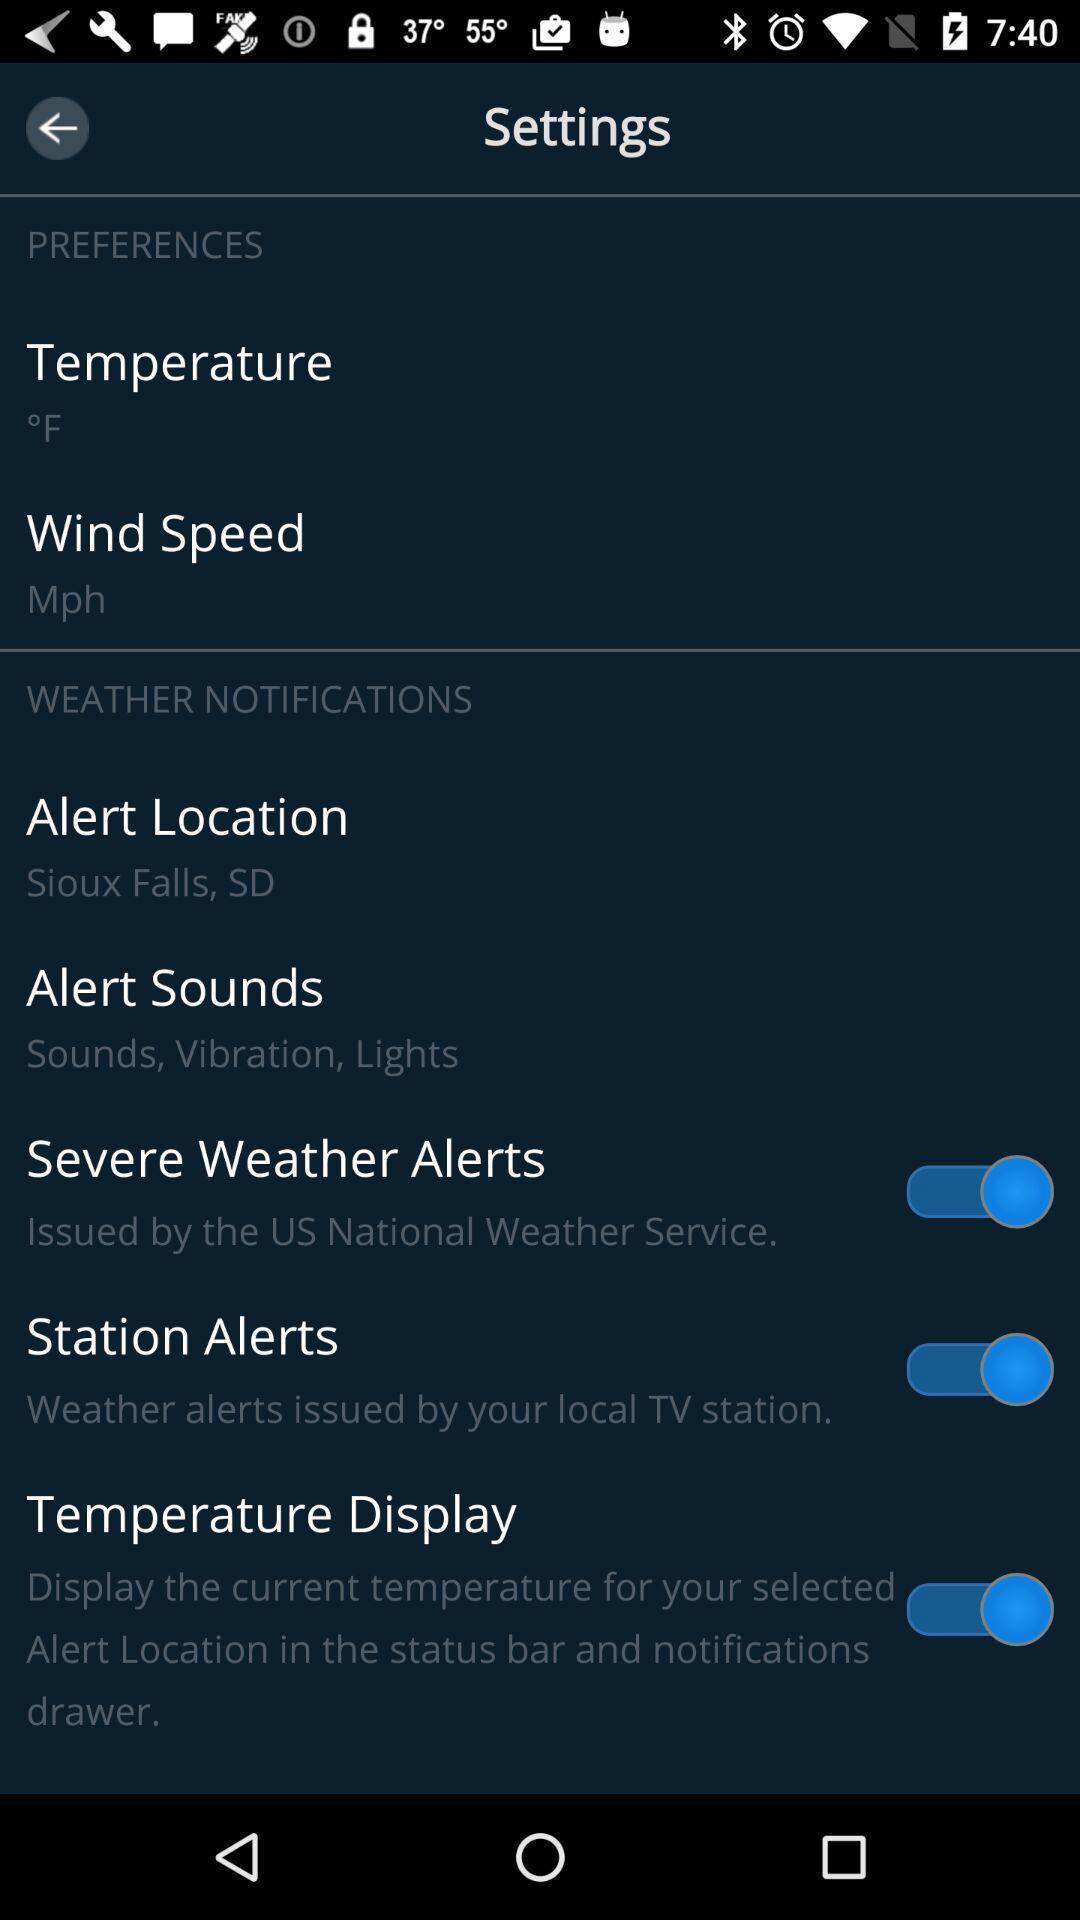Explain the elements present in this screenshot. Screen page of a settings in a weather app. 